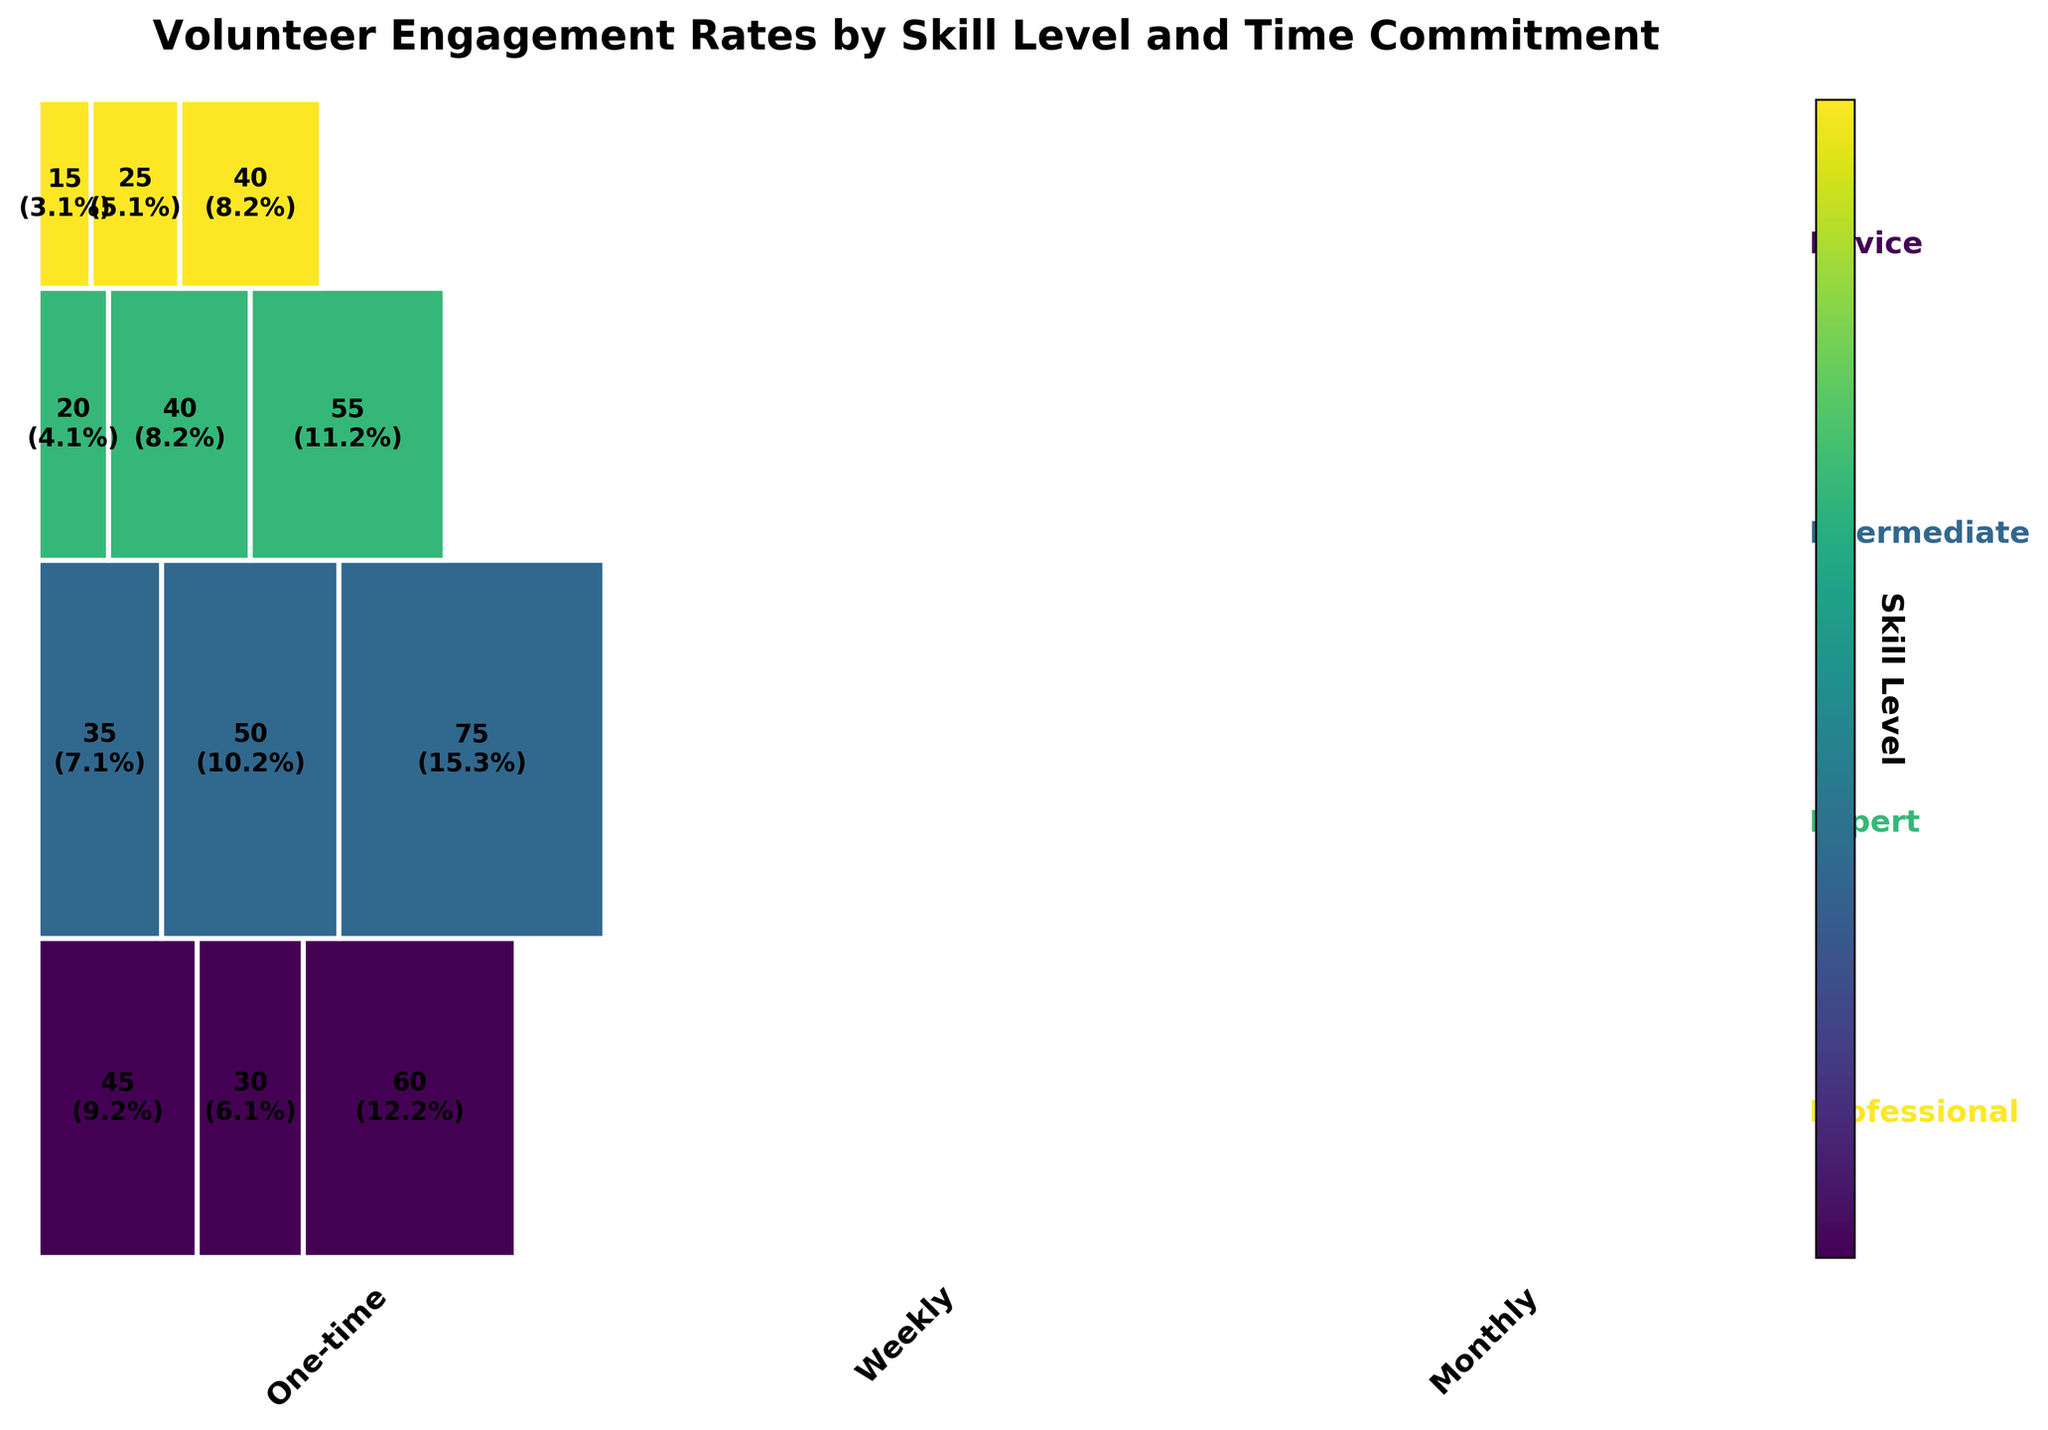What is the title of the mosaic plot? The mosaic plot has a single title which is located at the top of the figure.
Answer: Volunteer Engagement Rates by Skill Level and Time Commitment How are the skill levels represented in the plot? The different skill levels are represented by distinct, continuous bands of color that span horizontally across the plot.
Answer: Different colors Which time commitment category had the highest number of volunteers for Novice skill level? The plot breaks down each skill level into different time commitment categories, with each category's size indicating the number of volunteers. For Novice skill level, the area of the Monthly rectangle is the largest.
Answer: Monthly What proportion of the total volunteers are Intermediate skill level with Monthly commitment? Find the Intermediate category, then locate the Monthly rectangle within it. The proportion is indicated inside the rectangle. Intermediate Monthly has 75 volunteers. The proportion is 75/520.
Answer: Approximately 14.4% Compare the number of volunteers between Expert and Professional skill levels for Monthly commitments. Which is higher? Locate the Monthly commitment rectangles for both Expert and Professional skill levels. The numbers inside the rectangles indicate the count of volunteers. Expert has 55 volunteers while Professional has 40.
Answer: Expert Which skill level has the lowest total number of volunteers? Sum the volunteer counts for each skill level by visually aggregating the areas of their corresponding rectangles. Professional has the smallest sum (15+25+40).
Answer: Professional If we combine the Weekly and Monthly commitments, which skill level has the most volunteers? Sum the counts for Weekly and Monthly for each skill level. For Novice: 30+60=90, Intermediate: 50+75=125, Expert: 40+55=95, Professional: 25+40=65. Intermediate has the highest combined number.
Answer: Intermediate Which time commitment category has consistently fewer volunteers across all skill levels? Compare the sizes of rectangles for the three time commitment categories (One-time, Weekly, Monthly) across all skill levels. One-time rectangles are consistently smaller.
Answer: One-time How does the volunteer engagement for Weekly vs Monthly commitment compare for Intermediate skill level? Compare the size of the Weekly and Monthly rectangles within the Intermediate category. Monthly rectangle is larger (75) compared to Weekly (50).
Answer: Monthly is higher What is the total number of volunteers for the Expert skill level? Add up the number of volunteers for each time commitment within the Expert skill level (20 + 40 + 55). The total is 115.
Answer: 115 